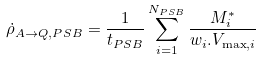Convert formula to latex. <formula><loc_0><loc_0><loc_500><loc_500>\dot { \rho } _ { A \rightarrow Q , P S B } = \frac { 1 } { t _ { P S B } } \sum _ { i = 1 } ^ { N _ { P S B } } \frac { M ^ { * } _ { i } } { w _ { i } . V _ { \max , i } }</formula> 